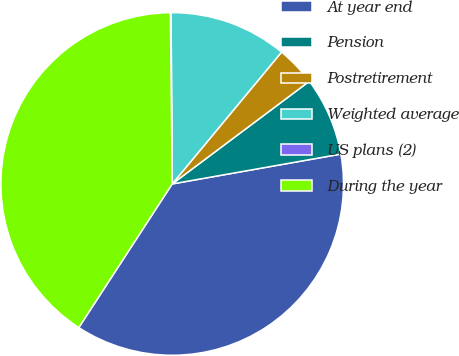Convert chart to OTSL. <chart><loc_0><loc_0><loc_500><loc_500><pie_chart><fcel>At year end<fcel>Pension<fcel>Postretirement<fcel>Weighted average<fcel>US plans (2)<fcel>During the year<nl><fcel>36.97%<fcel>7.44%<fcel>3.75%<fcel>11.13%<fcel>0.06%<fcel>40.66%<nl></chart> 